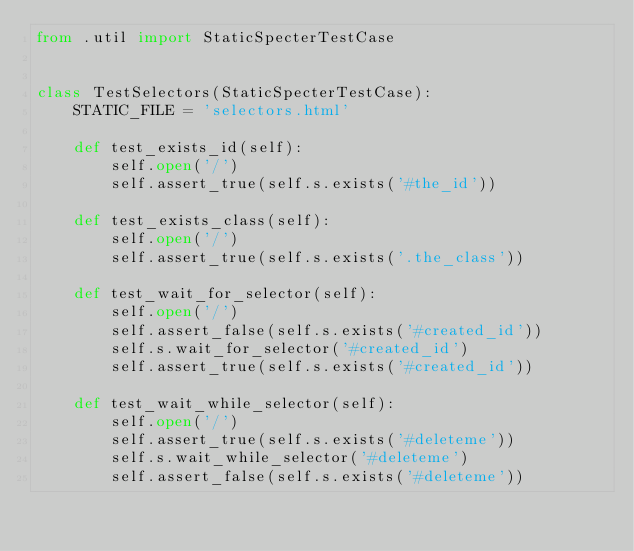Convert code to text. <code><loc_0><loc_0><loc_500><loc_500><_Python_>from .util import StaticSpecterTestCase


class TestSelectors(StaticSpecterTestCase):
    STATIC_FILE = 'selectors.html'

    def test_exists_id(self):
        self.open('/')
        self.assert_true(self.s.exists('#the_id'))

    def test_exists_class(self):
        self.open('/')
        self.assert_true(self.s.exists('.the_class'))

    def test_wait_for_selector(self):
        self.open('/')
        self.assert_false(self.s.exists('#created_id'))
        self.s.wait_for_selector('#created_id')
        self.assert_true(self.s.exists('#created_id'))

    def test_wait_while_selector(self):
        self.open('/')
        self.assert_true(self.s.exists('#deleteme'))
        self.s.wait_while_selector('#deleteme')
        self.assert_false(self.s.exists('#deleteme'))
</code> 